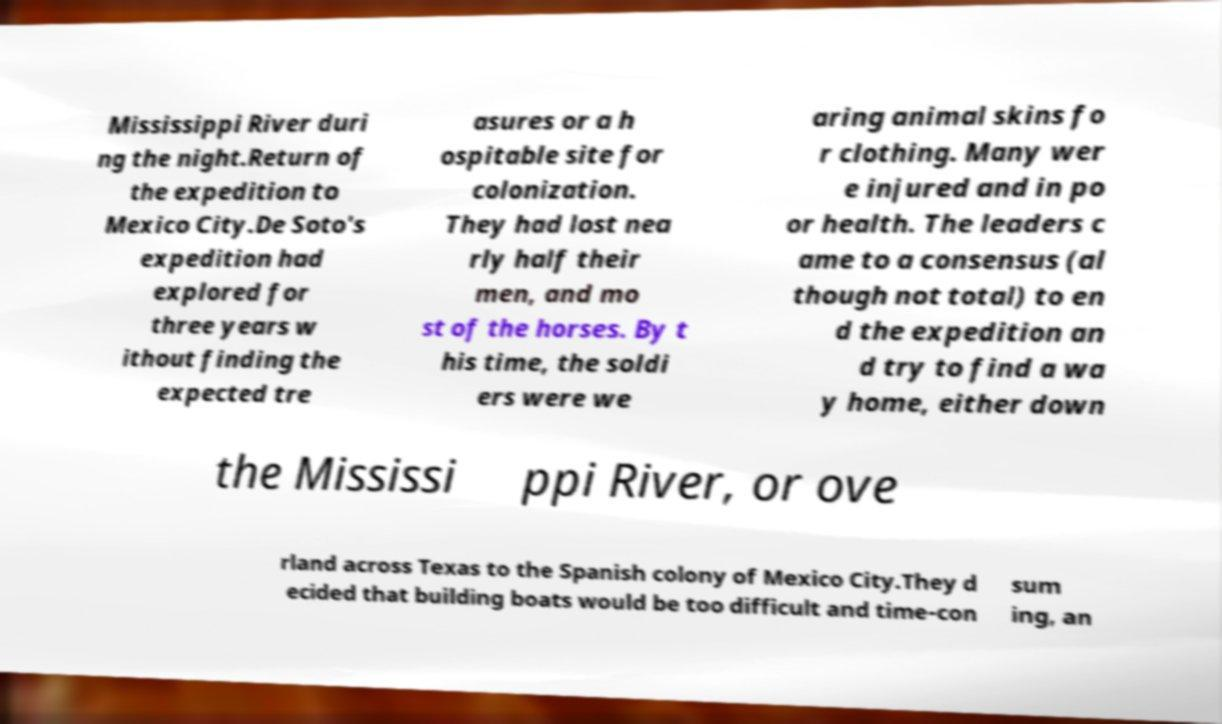I need the written content from this picture converted into text. Can you do that? Mississippi River duri ng the night.Return of the expedition to Mexico City.De Soto's expedition had explored for three years w ithout finding the expected tre asures or a h ospitable site for colonization. They had lost nea rly half their men, and mo st of the horses. By t his time, the soldi ers were we aring animal skins fo r clothing. Many wer e injured and in po or health. The leaders c ame to a consensus (al though not total) to en d the expedition an d try to find a wa y home, either down the Mississi ppi River, or ove rland across Texas to the Spanish colony of Mexico City.They d ecided that building boats would be too difficult and time-con sum ing, an 